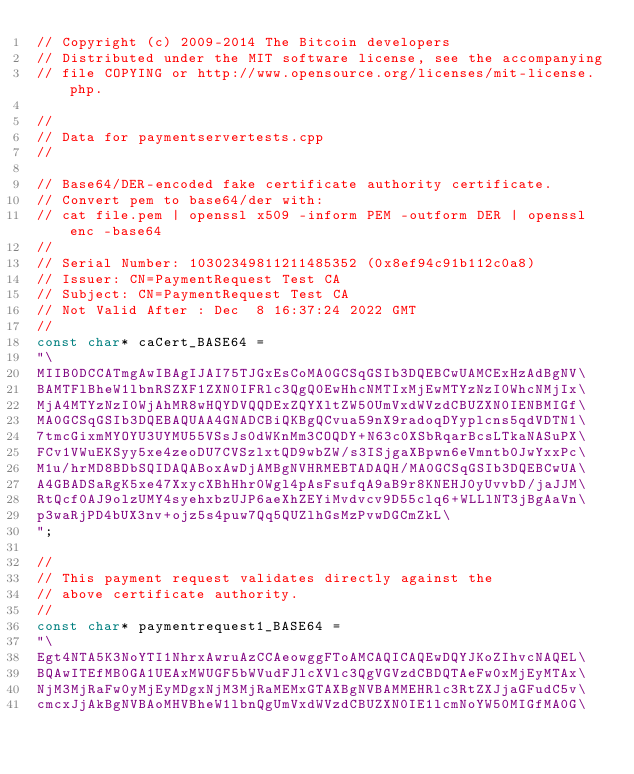Convert code to text. <code><loc_0><loc_0><loc_500><loc_500><_C_>// Copyright (c) 2009-2014 The Bitcoin developers
// Distributed under the MIT software license, see the accompanying
// file COPYING or http://www.opensource.org/licenses/mit-license.php.

//
// Data for paymentservertests.cpp
//

// Base64/DER-encoded fake certificate authority certificate.
// Convert pem to base64/der with:
// cat file.pem | openssl x509 -inform PEM -outform DER | openssl enc -base64
//
// Serial Number: 10302349811211485352 (0x8ef94c91b112c0a8)
// Issuer: CN=PaymentRequest Test CA
// Subject: CN=PaymentRequest Test CA
// Not Valid After : Dec  8 16:37:24 2022 GMT
//
const char* caCert_BASE64 =
"\
MIIB0DCCATmgAwIBAgIJAI75TJGxEsCoMA0GCSqGSIb3DQEBCwUAMCExHzAdBgNV\
BAMTFlBheW1lbnRSZXF1ZXN0IFRlc3QgQ0EwHhcNMTIxMjEwMTYzNzI0WhcNMjIx\
MjA4MTYzNzI0WjAhMR8wHQYDVQQDExZQYXltZW50UmVxdWVzdCBUZXN0IENBMIGf\
MA0GCSqGSIb3DQEBAQUAA4GNADCBiQKBgQCvua59nX9radoqDYyplcns5qdVDTN1\
7tmcGixmMYOYU3UYMU55VSsJs0dWKnMm3COQDY+N63c0XSbRqarBcsLTkaNASuPX\
FCv1VWuEKSyy5xe4zeoDU7CVSzlxtQD9wbZW/s3ISjgaXBpwn6eVmntb0JwYxxPc\
M1u/hrMD8BDbSQIDAQABoxAwDjAMBgNVHRMEBTADAQH/MA0GCSqGSIb3DQEBCwUA\
A4GBADSaRgK5xe47XxycXBhHhr0Wgl4pAsFsufqA9aB9r8KNEHJ0yUvvbD/jaJJM\
RtQcf0AJ9olzUMY4syehxbzUJP6aeXhZEYiMvdvcv9D55clq6+WLLlNT3jBgAaVn\
p3waRjPD4bUX3nv+ojz5s4puw7Qq5QUZlhGsMzPvwDGCmZkL\
";

//
// This payment request validates directly against the
// above certificate authority.
//
const char* paymentrequest1_BASE64 =
"\
Egt4NTA5K3NoYTI1NhrxAwruAzCCAeowggFToAMCAQICAQEwDQYJKoZIhvcNAQEL\
BQAwITEfMB0GA1UEAxMWUGF5bWVudFJlcXVlc3QgVGVzdCBDQTAeFw0xMjEyMTAx\
NjM3MjRaFw0yMjEyMDgxNjM3MjRaMEMxGTAXBgNVBAMMEHRlc3RtZXJjaGFudC5v\
cmcxJjAkBgNVBAoMHVBheW1lbnQgUmVxdWVzdCBUZXN0IE1lcmNoYW50MIGfMA0G\</code> 